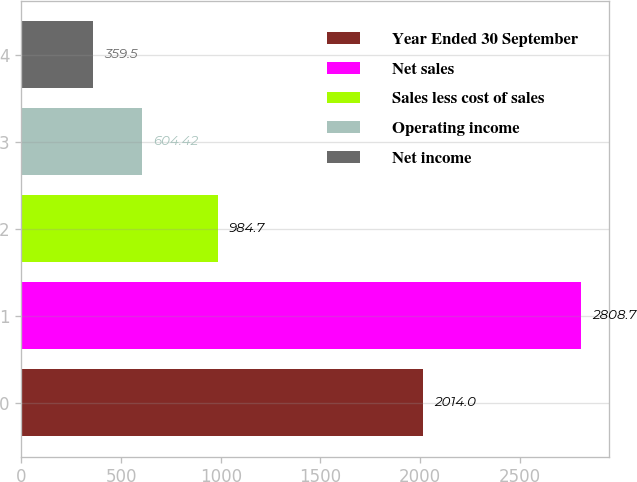Convert chart. <chart><loc_0><loc_0><loc_500><loc_500><bar_chart><fcel>Year Ended 30 September<fcel>Net sales<fcel>Sales less cost of sales<fcel>Operating income<fcel>Net income<nl><fcel>2014<fcel>2808.7<fcel>984.7<fcel>604.42<fcel>359.5<nl></chart> 